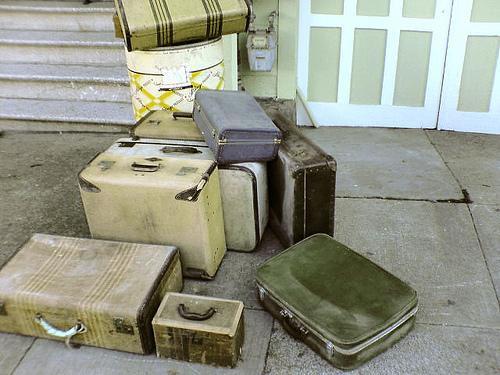How many suitcases are pictured?
Concise answer only. 10. Are the suitcases inside an elevator?
Be succinct. No. How many pieces of luggage are white?
Concise answer only. 4. What material is the floor made of?
Be succinct. Concrete. What color is the luggage?
Write a very short answer. Green. What is the suitcases for?
Quick response, please. Traveling. How many pieces of luggage?
Be succinct. 10. How many suitcases are green?
Write a very short answer. 1. Are these suitcases new?
Give a very brief answer. No. What appliance is abandoned here?
Be succinct. Luggage. 